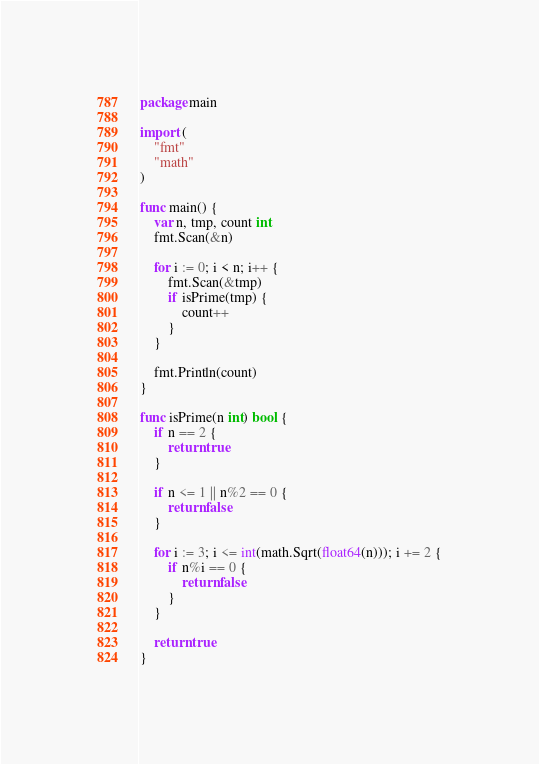<code> <loc_0><loc_0><loc_500><loc_500><_Go_>package main

import (
	"fmt"
	"math"
)

func main() {
	var n, tmp, count int
	fmt.Scan(&n)

	for i := 0; i < n; i++ {
		fmt.Scan(&tmp)
		if isPrime(tmp) {
			count++
		}
	}

	fmt.Println(count)
}

func isPrime(n int) bool {
	if n == 2 {
		return true
	}

	if n <= 1 || n%2 == 0 {
		return false
	}

	for i := 3; i <= int(math.Sqrt(float64(n))); i += 2 {
		if n%i == 0 {
			return false
		}
	}

	return true
}</code> 